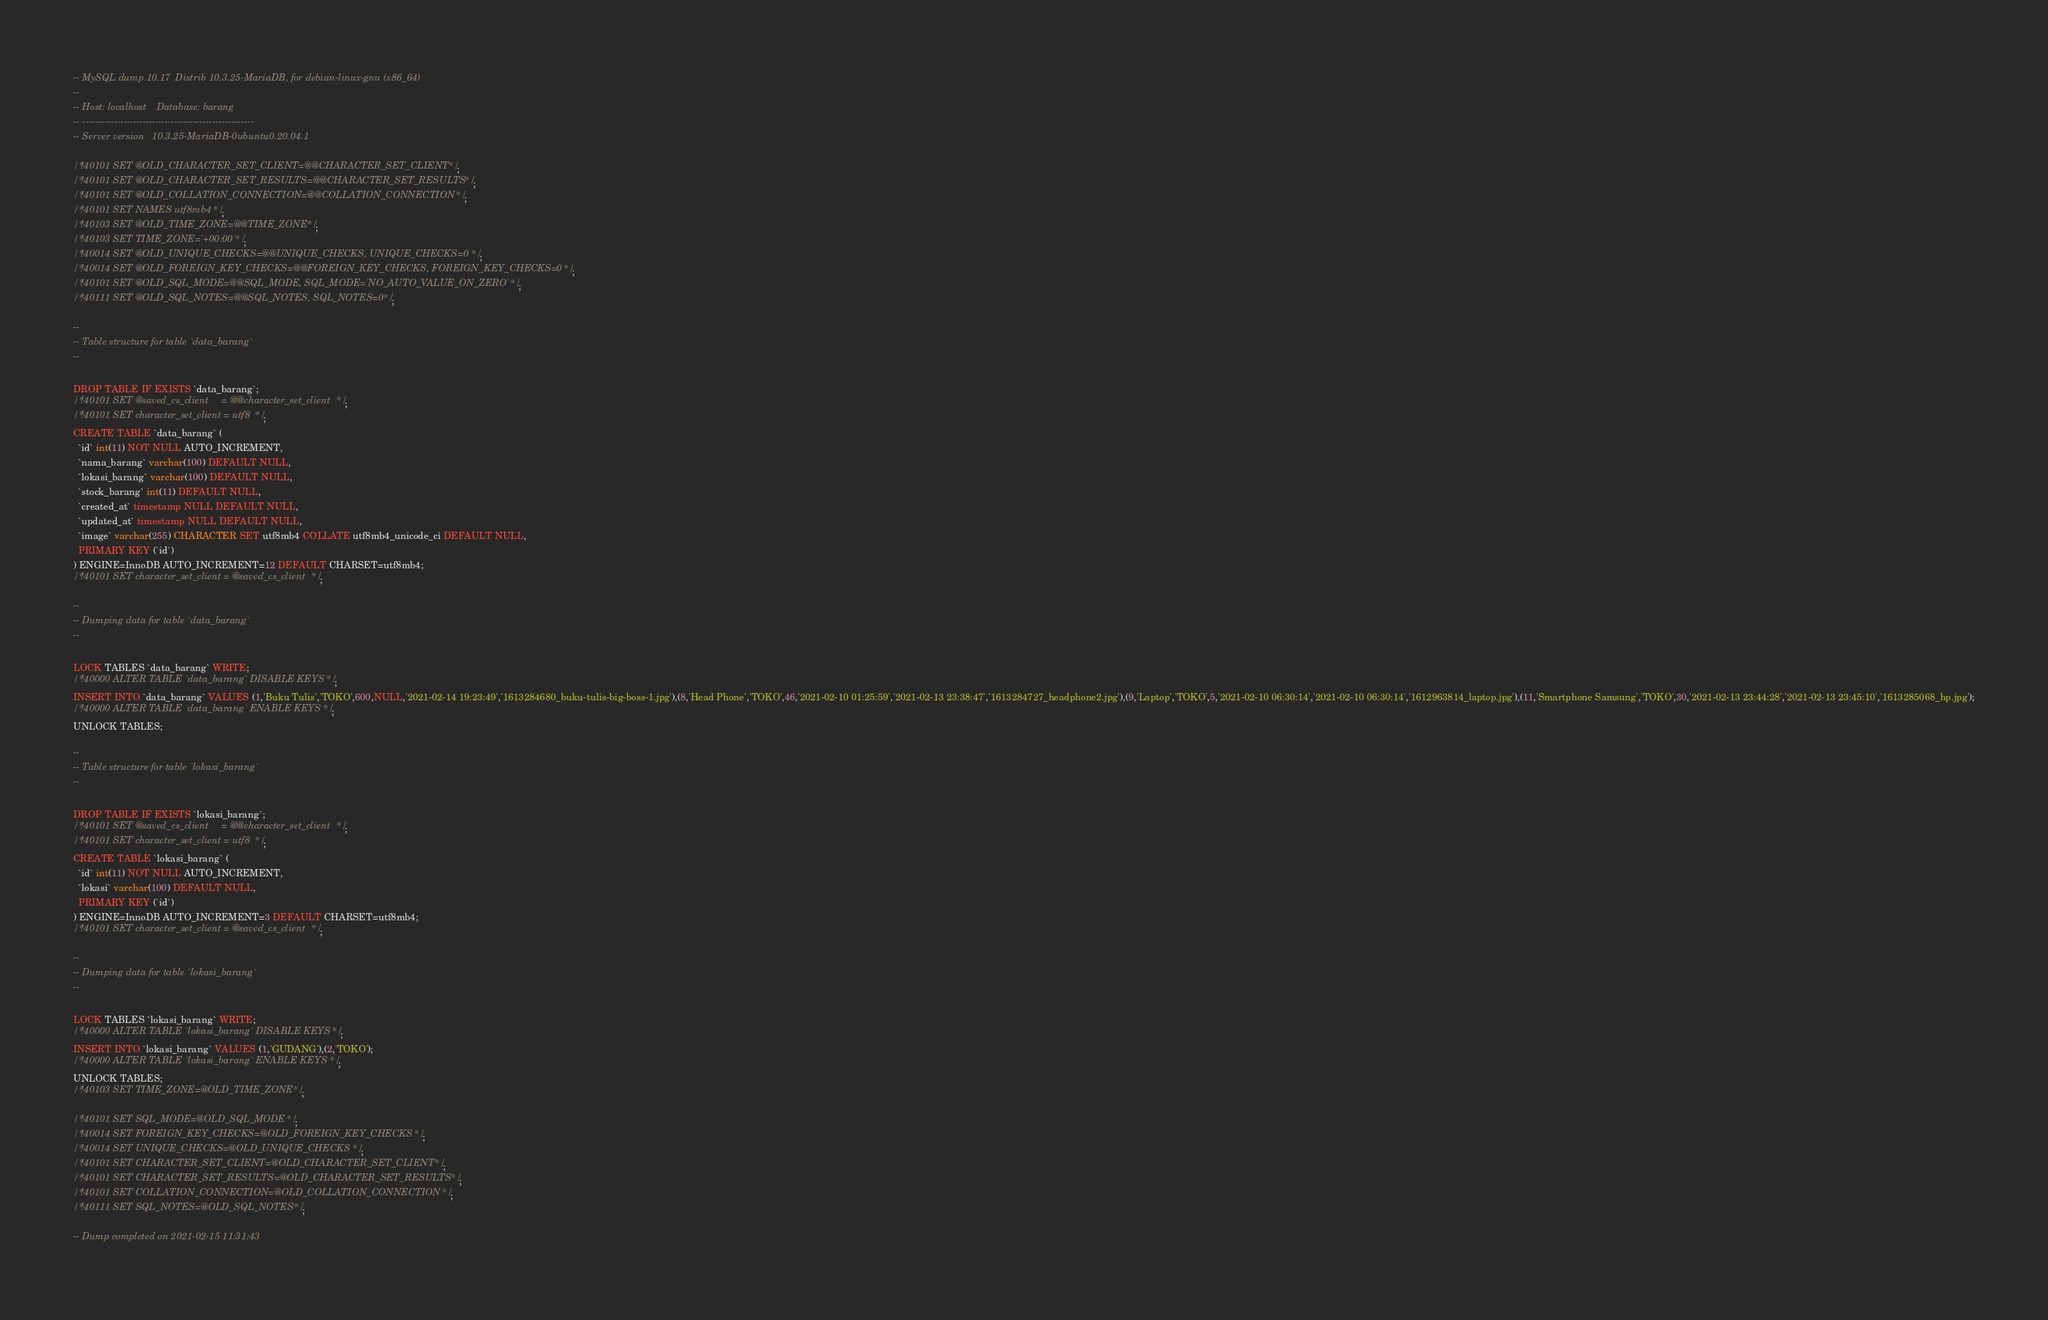<code> <loc_0><loc_0><loc_500><loc_500><_SQL_>-- MySQL dump 10.17  Distrib 10.3.25-MariaDB, for debian-linux-gnu (x86_64)
--
-- Host: localhost    Database: barang
-- ------------------------------------------------------
-- Server version	10.3.25-MariaDB-0ubuntu0.20.04.1

/*!40101 SET @OLD_CHARACTER_SET_CLIENT=@@CHARACTER_SET_CLIENT */;
/*!40101 SET @OLD_CHARACTER_SET_RESULTS=@@CHARACTER_SET_RESULTS */;
/*!40101 SET @OLD_COLLATION_CONNECTION=@@COLLATION_CONNECTION */;
/*!40101 SET NAMES utf8mb4 */;
/*!40103 SET @OLD_TIME_ZONE=@@TIME_ZONE */;
/*!40103 SET TIME_ZONE='+00:00' */;
/*!40014 SET @OLD_UNIQUE_CHECKS=@@UNIQUE_CHECKS, UNIQUE_CHECKS=0 */;
/*!40014 SET @OLD_FOREIGN_KEY_CHECKS=@@FOREIGN_KEY_CHECKS, FOREIGN_KEY_CHECKS=0 */;
/*!40101 SET @OLD_SQL_MODE=@@SQL_MODE, SQL_MODE='NO_AUTO_VALUE_ON_ZERO' */;
/*!40111 SET @OLD_SQL_NOTES=@@SQL_NOTES, SQL_NOTES=0 */;

--
-- Table structure for table `data_barang`
--

DROP TABLE IF EXISTS `data_barang`;
/*!40101 SET @saved_cs_client     = @@character_set_client */;
/*!40101 SET character_set_client = utf8 */;
CREATE TABLE `data_barang` (
  `id` int(11) NOT NULL AUTO_INCREMENT,
  `nama_barang` varchar(100) DEFAULT NULL,
  `lokasi_barang` varchar(100) DEFAULT NULL,
  `stock_barang` int(11) DEFAULT NULL,
  `created_at` timestamp NULL DEFAULT NULL,
  `updated_at` timestamp NULL DEFAULT NULL,
  `image` varchar(255) CHARACTER SET utf8mb4 COLLATE utf8mb4_unicode_ci DEFAULT NULL,
  PRIMARY KEY (`id`)
) ENGINE=InnoDB AUTO_INCREMENT=12 DEFAULT CHARSET=utf8mb4;
/*!40101 SET character_set_client = @saved_cs_client */;

--
-- Dumping data for table `data_barang`
--

LOCK TABLES `data_barang` WRITE;
/*!40000 ALTER TABLE `data_barang` DISABLE KEYS */;
INSERT INTO `data_barang` VALUES (1,'Buku Tulis','TOKO',600,NULL,'2021-02-14 19:23:49','1613284680_buku-tulis-big-boss-1.jpg'),(8,'Head Phone','TOKO',46,'2021-02-10 01:25:59','2021-02-13 23:38:47','1613284727_headphone2.jpg'),(9,'Laptop','TOKO',5,'2021-02-10 06:30:14','2021-02-10 06:30:14','1612963814_laptop.jpg'),(11,'Smartphone Samsung','TOKO',30,'2021-02-13 23:44:28','2021-02-13 23:45:10','1613285068_hp.jpg');
/*!40000 ALTER TABLE `data_barang` ENABLE KEYS */;
UNLOCK TABLES;

--
-- Table structure for table `lokasi_barang`
--

DROP TABLE IF EXISTS `lokasi_barang`;
/*!40101 SET @saved_cs_client     = @@character_set_client */;
/*!40101 SET character_set_client = utf8 */;
CREATE TABLE `lokasi_barang` (
  `id` int(11) NOT NULL AUTO_INCREMENT,
  `lokasi` varchar(100) DEFAULT NULL,
  PRIMARY KEY (`id`)
) ENGINE=InnoDB AUTO_INCREMENT=3 DEFAULT CHARSET=utf8mb4;
/*!40101 SET character_set_client = @saved_cs_client */;

--
-- Dumping data for table `lokasi_barang`
--

LOCK TABLES `lokasi_barang` WRITE;
/*!40000 ALTER TABLE `lokasi_barang` DISABLE KEYS */;
INSERT INTO `lokasi_barang` VALUES (1,'GUDANG'),(2,'TOKO');
/*!40000 ALTER TABLE `lokasi_barang` ENABLE KEYS */;
UNLOCK TABLES;
/*!40103 SET TIME_ZONE=@OLD_TIME_ZONE */;

/*!40101 SET SQL_MODE=@OLD_SQL_MODE */;
/*!40014 SET FOREIGN_KEY_CHECKS=@OLD_FOREIGN_KEY_CHECKS */;
/*!40014 SET UNIQUE_CHECKS=@OLD_UNIQUE_CHECKS */;
/*!40101 SET CHARACTER_SET_CLIENT=@OLD_CHARACTER_SET_CLIENT */;
/*!40101 SET CHARACTER_SET_RESULTS=@OLD_CHARACTER_SET_RESULTS */;
/*!40101 SET COLLATION_CONNECTION=@OLD_COLLATION_CONNECTION */;
/*!40111 SET SQL_NOTES=@OLD_SQL_NOTES */;

-- Dump completed on 2021-02-15 11:31:43
</code> 